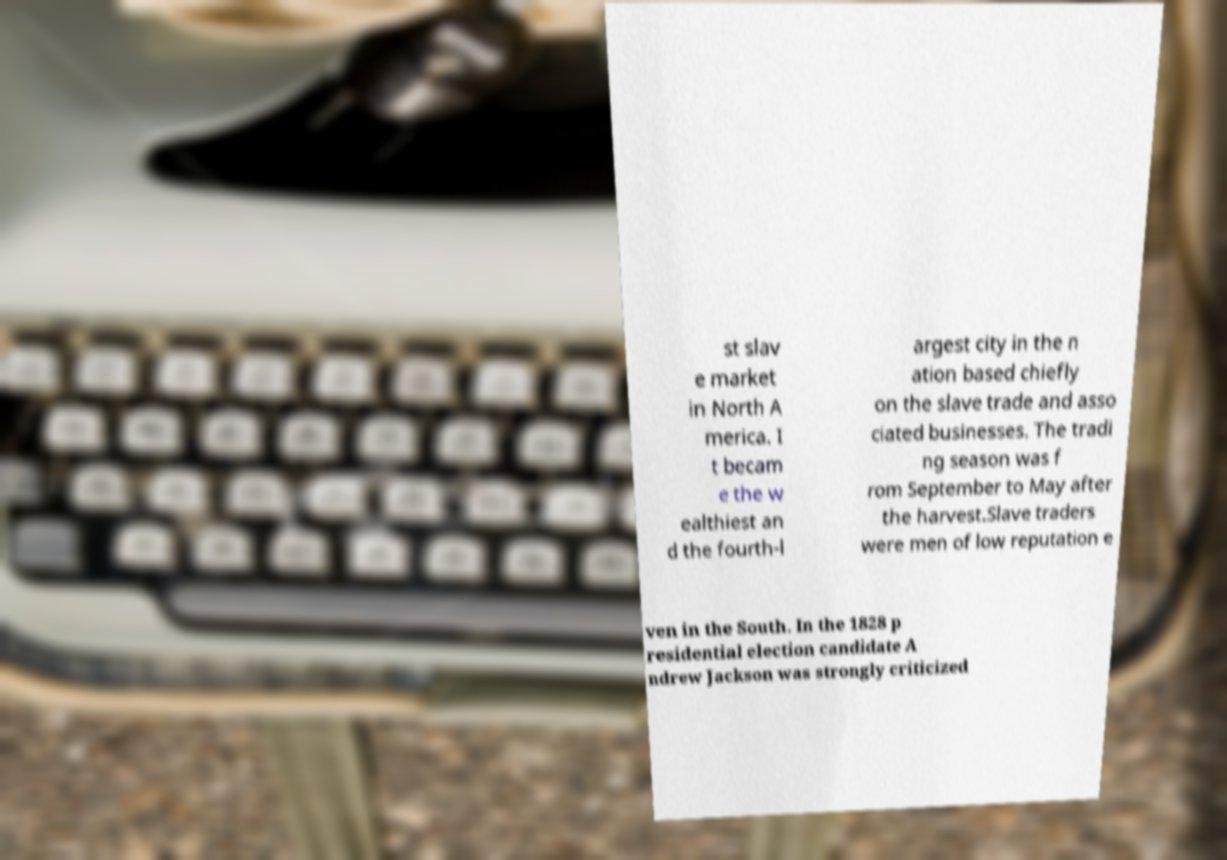Please identify and transcribe the text found in this image. st slav e market in North A merica. I t becam e the w ealthiest an d the fourth-l argest city in the n ation based chiefly on the slave trade and asso ciated businesses. The tradi ng season was f rom September to May after the harvest.Slave traders were men of low reputation e ven in the South. In the 1828 p residential election candidate A ndrew Jackson was strongly criticized 